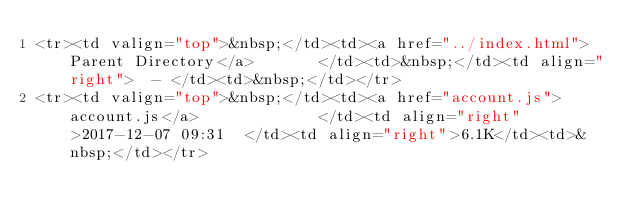Convert code to text. <code><loc_0><loc_0><loc_500><loc_500><_HTML_><tr><td valign="top">&nbsp;</td><td><a href="../index.html">Parent Directory</a>       </td><td>&nbsp;</td><td align="right">  - </td><td>&nbsp;</td></tr>
<tr><td valign="top">&nbsp;</td><td><a href="account.js">account.js</a>             </td><td align="right">2017-12-07 09:31  </td><td align="right">6.1K</td><td>&nbsp;</td></tr></code> 